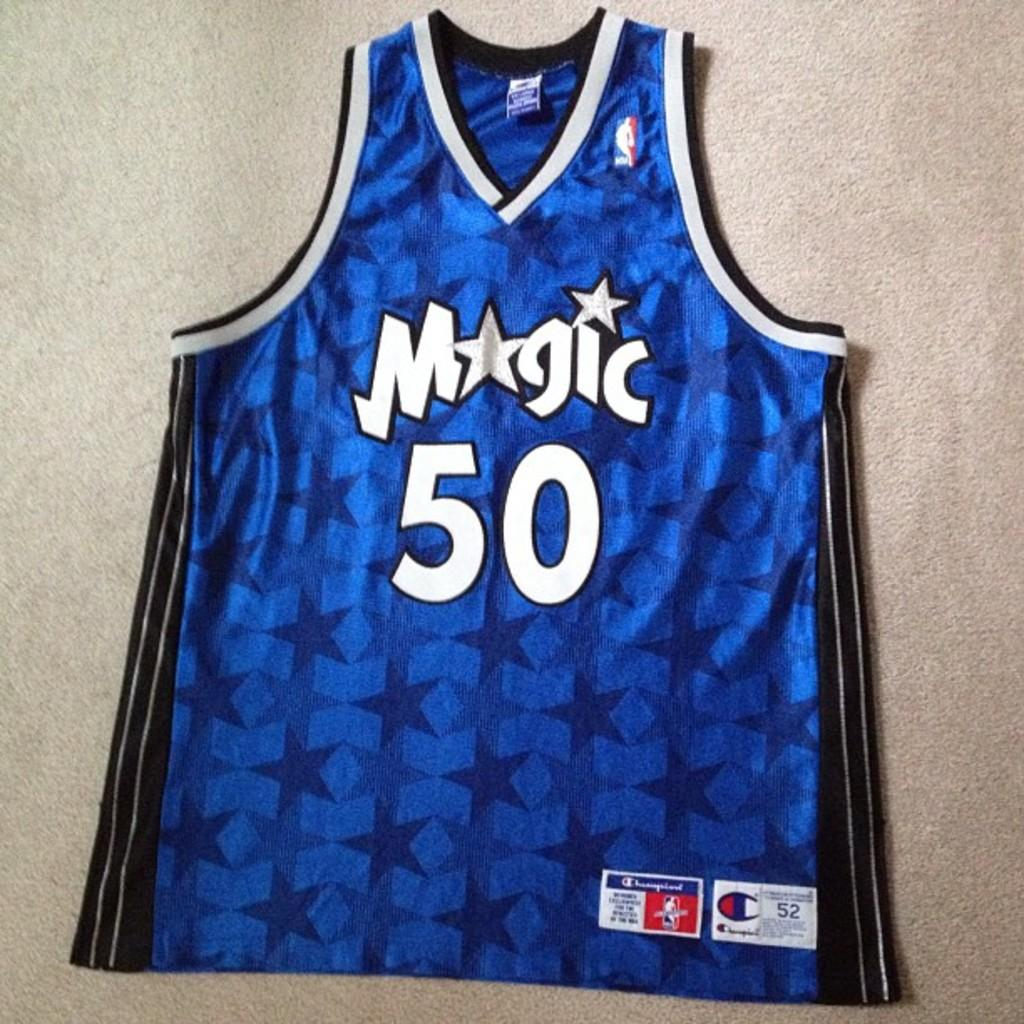Provide a one-sentence caption for the provided image. Blue magic jersey with the number fifty wrote on it. 